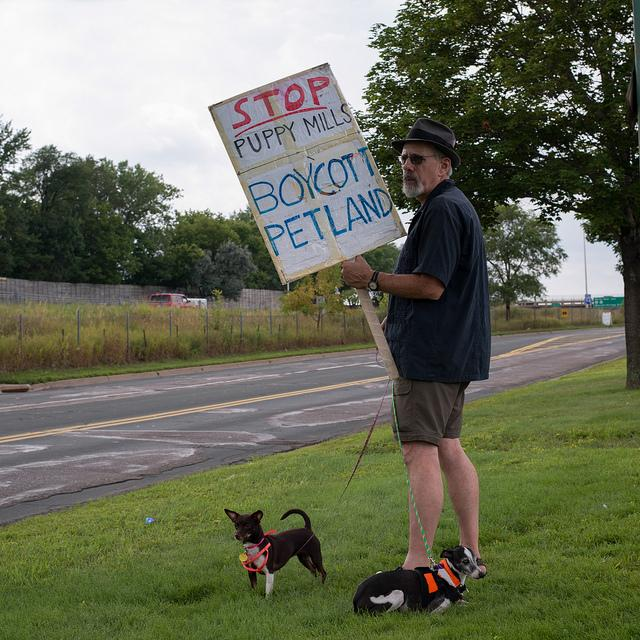What sort of life does this man advocate for?

Choices:
A) merchants
B) canines
C) felines
D) people canines 